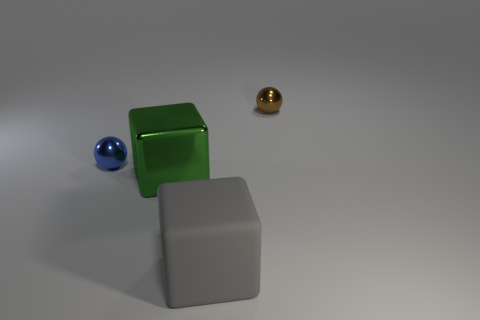There is a blue thing; does it have the same size as the metal object right of the gray object?
Ensure brevity in your answer.  Yes. What color is the tiny sphere that is in front of the tiny shiny sphere that is to the right of the blue object?
Provide a succinct answer. Blue. Is the number of green metal blocks that are to the right of the large green object the same as the number of green things to the left of the rubber cube?
Provide a succinct answer. No. Is the thing on the right side of the gray thing made of the same material as the gray object?
Your answer should be compact. No. The thing that is behind the large green block and on the left side of the big rubber thing is what color?
Give a very brief answer. Blue. What number of metal objects are in front of the small shiny ball left of the gray matte cube?
Offer a terse response. 1. What material is the gray object that is the same shape as the big green shiny object?
Provide a short and direct response. Rubber. The shiny cube has what color?
Provide a short and direct response. Green. What number of things are green objects or blue balls?
Your answer should be very brief. 2. What shape is the tiny thing left of the large object in front of the large shiny thing?
Keep it short and to the point. Sphere. 